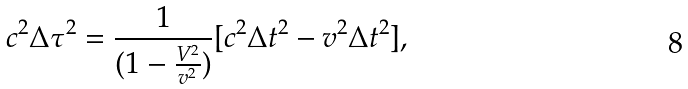Convert formula to latex. <formula><loc_0><loc_0><loc_500><loc_500>c ^ { 2 } \Delta \tau ^ { 2 } = \frac { 1 } { ( 1 - \frac { V ^ { 2 } } { v ^ { 2 } } ) } [ c ^ { 2 } \Delta t ^ { 2 } - v ^ { 2 } \Delta t ^ { 2 } ] ,</formula> 